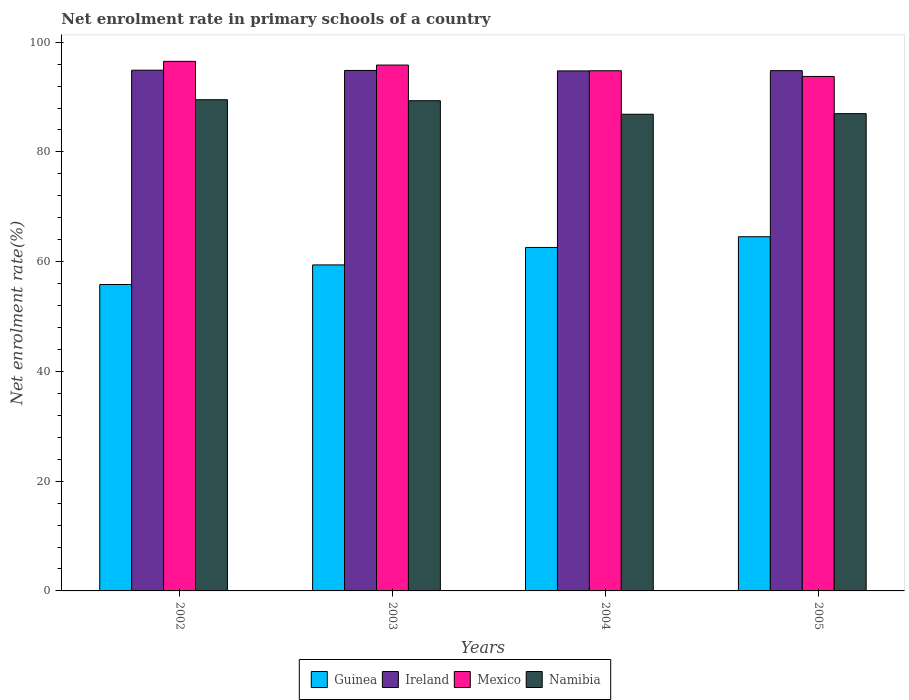How many different coloured bars are there?
Make the answer very short. 4. Are the number of bars per tick equal to the number of legend labels?
Offer a very short reply. Yes. How many bars are there on the 4th tick from the left?
Give a very brief answer. 4. What is the label of the 1st group of bars from the left?
Keep it short and to the point. 2002. In how many cases, is the number of bars for a given year not equal to the number of legend labels?
Your answer should be compact. 0. What is the net enrolment rate in primary schools in Ireland in 2003?
Your answer should be compact. 94.85. Across all years, what is the maximum net enrolment rate in primary schools in Mexico?
Your answer should be very brief. 96.51. Across all years, what is the minimum net enrolment rate in primary schools in Guinea?
Give a very brief answer. 55.84. In which year was the net enrolment rate in primary schools in Ireland maximum?
Ensure brevity in your answer.  2002. In which year was the net enrolment rate in primary schools in Ireland minimum?
Provide a short and direct response. 2004. What is the total net enrolment rate in primary schools in Guinea in the graph?
Your answer should be compact. 242.38. What is the difference between the net enrolment rate in primary schools in Ireland in 2002 and that in 2005?
Keep it short and to the point. 0.08. What is the difference between the net enrolment rate in primary schools in Mexico in 2003 and the net enrolment rate in primary schools in Ireland in 2002?
Give a very brief answer. 0.94. What is the average net enrolment rate in primary schools in Guinea per year?
Provide a short and direct response. 60.59. In the year 2003, what is the difference between the net enrolment rate in primary schools in Mexico and net enrolment rate in primary schools in Namibia?
Provide a short and direct response. 6.5. In how many years, is the net enrolment rate in primary schools in Namibia greater than 84 %?
Your answer should be compact. 4. What is the ratio of the net enrolment rate in primary schools in Ireland in 2003 to that in 2004?
Offer a terse response. 1. Is the net enrolment rate in primary schools in Mexico in 2003 less than that in 2005?
Give a very brief answer. No. What is the difference between the highest and the second highest net enrolment rate in primary schools in Guinea?
Make the answer very short. 1.95. What is the difference between the highest and the lowest net enrolment rate in primary schools in Guinea?
Provide a short and direct response. 8.71. In how many years, is the net enrolment rate in primary schools in Guinea greater than the average net enrolment rate in primary schools in Guinea taken over all years?
Keep it short and to the point. 2. What does the 1st bar from the left in 2002 represents?
Keep it short and to the point. Guinea. What does the 1st bar from the right in 2002 represents?
Your answer should be compact. Namibia. Is it the case that in every year, the sum of the net enrolment rate in primary schools in Mexico and net enrolment rate in primary schools in Ireland is greater than the net enrolment rate in primary schools in Namibia?
Your answer should be compact. Yes. How many bars are there?
Your response must be concise. 16. What is the difference between two consecutive major ticks on the Y-axis?
Give a very brief answer. 20. Does the graph contain any zero values?
Your response must be concise. No. Does the graph contain grids?
Offer a very short reply. No. How many legend labels are there?
Your answer should be compact. 4. What is the title of the graph?
Give a very brief answer. Net enrolment rate in primary schools of a country. Does "San Marino" appear as one of the legend labels in the graph?
Give a very brief answer. No. What is the label or title of the X-axis?
Provide a succinct answer. Years. What is the label or title of the Y-axis?
Offer a terse response. Net enrolment rate(%). What is the Net enrolment rate(%) in Guinea in 2002?
Ensure brevity in your answer.  55.84. What is the Net enrolment rate(%) in Ireland in 2002?
Give a very brief answer. 94.89. What is the Net enrolment rate(%) of Mexico in 2002?
Offer a very short reply. 96.51. What is the Net enrolment rate(%) in Namibia in 2002?
Provide a short and direct response. 89.51. What is the Net enrolment rate(%) of Guinea in 2003?
Offer a very short reply. 59.41. What is the Net enrolment rate(%) in Ireland in 2003?
Your answer should be very brief. 94.85. What is the Net enrolment rate(%) in Mexico in 2003?
Offer a terse response. 95.83. What is the Net enrolment rate(%) of Namibia in 2003?
Offer a very short reply. 89.33. What is the Net enrolment rate(%) in Guinea in 2004?
Offer a very short reply. 62.59. What is the Net enrolment rate(%) of Ireland in 2004?
Provide a short and direct response. 94.77. What is the Net enrolment rate(%) of Mexico in 2004?
Give a very brief answer. 94.8. What is the Net enrolment rate(%) of Namibia in 2004?
Provide a short and direct response. 86.87. What is the Net enrolment rate(%) of Guinea in 2005?
Keep it short and to the point. 64.54. What is the Net enrolment rate(%) of Ireland in 2005?
Give a very brief answer. 94.81. What is the Net enrolment rate(%) of Mexico in 2005?
Offer a very short reply. 93.75. What is the Net enrolment rate(%) of Namibia in 2005?
Your answer should be very brief. 86.98. Across all years, what is the maximum Net enrolment rate(%) of Guinea?
Make the answer very short. 64.54. Across all years, what is the maximum Net enrolment rate(%) of Ireland?
Offer a terse response. 94.89. Across all years, what is the maximum Net enrolment rate(%) in Mexico?
Make the answer very short. 96.51. Across all years, what is the maximum Net enrolment rate(%) in Namibia?
Offer a very short reply. 89.51. Across all years, what is the minimum Net enrolment rate(%) in Guinea?
Offer a terse response. 55.84. Across all years, what is the minimum Net enrolment rate(%) in Ireland?
Your answer should be very brief. 94.77. Across all years, what is the minimum Net enrolment rate(%) in Mexico?
Your response must be concise. 93.75. Across all years, what is the minimum Net enrolment rate(%) of Namibia?
Provide a short and direct response. 86.87. What is the total Net enrolment rate(%) in Guinea in the graph?
Your response must be concise. 242.38. What is the total Net enrolment rate(%) in Ireland in the graph?
Offer a very short reply. 379.32. What is the total Net enrolment rate(%) of Mexico in the graph?
Provide a succinct answer. 380.89. What is the total Net enrolment rate(%) of Namibia in the graph?
Offer a terse response. 352.69. What is the difference between the Net enrolment rate(%) of Guinea in 2002 and that in 2003?
Keep it short and to the point. -3.57. What is the difference between the Net enrolment rate(%) of Ireland in 2002 and that in 2003?
Your answer should be compact. 0.05. What is the difference between the Net enrolment rate(%) in Mexico in 2002 and that in 2003?
Provide a succinct answer. 0.68. What is the difference between the Net enrolment rate(%) in Namibia in 2002 and that in 2003?
Your response must be concise. 0.18. What is the difference between the Net enrolment rate(%) in Guinea in 2002 and that in 2004?
Provide a short and direct response. -6.75. What is the difference between the Net enrolment rate(%) of Ireland in 2002 and that in 2004?
Your answer should be very brief. 0.13. What is the difference between the Net enrolment rate(%) in Mexico in 2002 and that in 2004?
Your answer should be compact. 1.71. What is the difference between the Net enrolment rate(%) of Namibia in 2002 and that in 2004?
Offer a terse response. 2.65. What is the difference between the Net enrolment rate(%) of Guinea in 2002 and that in 2005?
Offer a terse response. -8.71. What is the difference between the Net enrolment rate(%) in Ireland in 2002 and that in 2005?
Provide a short and direct response. 0.08. What is the difference between the Net enrolment rate(%) in Mexico in 2002 and that in 2005?
Provide a short and direct response. 2.75. What is the difference between the Net enrolment rate(%) in Namibia in 2002 and that in 2005?
Offer a terse response. 2.54. What is the difference between the Net enrolment rate(%) in Guinea in 2003 and that in 2004?
Provide a short and direct response. -3.18. What is the difference between the Net enrolment rate(%) in Ireland in 2003 and that in 2004?
Offer a very short reply. 0.08. What is the difference between the Net enrolment rate(%) of Mexico in 2003 and that in 2004?
Your answer should be compact. 1.03. What is the difference between the Net enrolment rate(%) of Namibia in 2003 and that in 2004?
Offer a very short reply. 2.47. What is the difference between the Net enrolment rate(%) of Guinea in 2003 and that in 2005?
Your answer should be very brief. -5.13. What is the difference between the Net enrolment rate(%) in Ireland in 2003 and that in 2005?
Ensure brevity in your answer.  0.03. What is the difference between the Net enrolment rate(%) in Mexico in 2003 and that in 2005?
Your response must be concise. 2.08. What is the difference between the Net enrolment rate(%) of Namibia in 2003 and that in 2005?
Provide a succinct answer. 2.36. What is the difference between the Net enrolment rate(%) of Guinea in 2004 and that in 2005?
Provide a succinct answer. -1.95. What is the difference between the Net enrolment rate(%) of Ireland in 2004 and that in 2005?
Make the answer very short. -0.05. What is the difference between the Net enrolment rate(%) of Mexico in 2004 and that in 2005?
Your response must be concise. 1.04. What is the difference between the Net enrolment rate(%) of Namibia in 2004 and that in 2005?
Your response must be concise. -0.11. What is the difference between the Net enrolment rate(%) of Guinea in 2002 and the Net enrolment rate(%) of Ireland in 2003?
Provide a succinct answer. -39.01. What is the difference between the Net enrolment rate(%) of Guinea in 2002 and the Net enrolment rate(%) of Mexico in 2003?
Give a very brief answer. -40. What is the difference between the Net enrolment rate(%) of Guinea in 2002 and the Net enrolment rate(%) of Namibia in 2003?
Give a very brief answer. -33.5. What is the difference between the Net enrolment rate(%) in Ireland in 2002 and the Net enrolment rate(%) in Mexico in 2003?
Ensure brevity in your answer.  -0.94. What is the difference between the Net enrolment rate(%) of Ireland in 2002 and the Net enrolment rate(%) of Namibia in 2003?
Your answer should be very brief. 5.56. What is the difference between the Net enrolment rate(%) of Mexico in 2002 and the Net enrolment rate(%) of Namibia in 2003?
Your response must be concise. 7.17. What is the difference between the Net enrolment rate(%) in Guinea in 2002 and the Net enrolment rate(%) in Ireland in 2004?
Provide a short and direct response. -38.93. What is the difference between the Net enrolment rate(%) in Guinea in 2002 and the Net enrolment rate(%) in Mexico in 2004?
Provide a short and direct response. -38.96. What is the difference between the Net enrolment rate(%) of Guinea in 2002 and the Net enrolment rate(%) of Namibia in 2004?
Provide a succinct answer. -31.03. What is the difference between the Net enrolment rate(%) of Ireland in 2002 and the Net enrolment rate(%) of Mexico in 2004?
Your answer should be very brief. 0.1. What is the difference between the Net enrolment rate(%) in Ireland in 2002 and the Net enrolment rate(%) in Namibia in 2004?
Your answer should be compact. 8.03. What is the difference between the Net enrolment rate(%) in Mexico in 2002 and the Net enrolment rate(%) in Namibia in 2004?
Offer a very short reply. 9.64. What is the difference between the Net enrolment rate(%) in Guinea in 2002 and the Net enrolment rate(%) in Ireland in 2005?
Offer a very short reply. -38.98. What is the difference between the Net enrolment rate(%) in Guinea in 2002 and the Net enrolment rate(%) in Mexico in 2005?
Offer a terse response. -37.92. What is the difference between the Net enrolment rate(%) in Guinea in 2002 and the Net enrolment rate(%) in Namibia in 2005?
Provide a succinct answer. -31.14. What is the difference between the Net enrolment rate(%) in Ireland in 2002 and the Net enrolment rate(%) in Mexico in 2005?
Ensure brevity in your answer.  1.14. What is the difference between the Net enrolment rate(%) of Ireland in 2002 and the Net enrolment rate(%) of Namibia in 2005?
Offer a very short reply. 7.92. What is the difference between the Net enrolment rate(%) of Mexico in 2002 and the Net enrolment rate(%) of Namibia in 2005?
Provide a short and direct response. 9.53. What is the difference between the Net enrolment rate(%) in Guinea in 2003 and the Net enrolment rate(%) in Ireland in 2004?
Your answer should be very brief. -35.36. What is the difference between the Net enrolment rate(%) of Guinea in 2003 and the Net enrolment rate(%) of Mexico in 2004?
Offer a very short reply. -35.39. What is the difference between the Net enrolment rate(%) of Guinea in 2003 and the Net enrolment rate(%) of Namibia in 2004?
Offer a terse response. -27.46. What is the difference between the Net enrolment rate(%) in Ireland in 2003 and the Net enrolment rate(%) in Mexico in 2004?
Your response must be concise. 0.05. What is the difference between the Net enrolment rate(%) in Ireland in 2003 and the Net enrolment rate(%) in Namibia in 2004?
Make the answer very short. 7.98. What is the difference between the Net enrolment rate(%) of Mexico in 2003 and the Net enrolment rate(%) of Namibia in 2004?
Make the answer very short. 8.96. What is the difference between the Net enrolment rate(%) in Guinea in 2003 and the Net enrolment rate(%) in Ireland in 2005?
Your response must be concise. -35.4. What is the difference between the Net enrolment rate(%) in Guinea in 2003 and the Net enrolment rate(%) in Mexico in 2005?
Offer a terse response. -34.35. What is the difference between the Net enrolment rate(%) in Guinea in 2003 and the Net enrolment rate(%) in Namibia in 2005?
Offer a terse response. -27.57. What is the difference between the Net enrolment rate(%) in Ireland in 2003 and the Net enrolment rate(%) in Mexico in 2005?
Give a very brief answer. 1.09. What is the difference between the Net enrolment rate(%) in Ireland in 2003 and the Net enrolment rate(%) in Namibia in 2005?
Offer a terse response. 7.87. What is the difference between the Net enrolment rate(%) of Mexico in 2003 and the Net enrolment rate(%) of Namibia in 2005?
Make the answer very short. 8.85. What is the difference between the Net enrolment rate(%) of Guinea in 2004 and the Net enrolment rate(%) of Ireland in 2005?
Provide a short and direct response. -32.22. What is the difference between the Net enrolment rate(%) in Guinea in 2004 and the Net enrolment rate(%) in Mexico in 2005?
Your answer should be compact. -31.16. What is the difference between the Net enrolment rate(%) of Guinea in 2004 and the Net enrolment rate(%) of Namibia in 2005?
Offer a terse response. -24.39. What is the difference between the Net enrolment rate(%) in Ireland in 2004 and the Net enrolment rate(%) in Mexico in 2005?
Keep it short and to the point. 1.01. What is the difference between the Net enrolment rate(%) of Ireland in 2004 and the Net enrolment rate(%) of Namibia in 2005?
Your response must be concise. 7.79. What is the difference between the Net enrolment rate(%) of Mexico in 2004 and the Net enrolment rate(%) of Namibia in 2005?
Provide a succinct answer. 7.82. What is the average Net enrolment rate(%) in Guinea per year?
Your answer should be compact. 60.59. What is the average Net enrolment rate(%) of Ireland per year?
Give a very brief answer. 94.83. What is the average Net enrolment rate(%) in Mexico per year?
Offer a very short reply. 95.22. What is the average Net enrolment rate(%) of Namibia per year?
Make the answer very short. 88.17. In the year 2002, what is the difference between the Net enrolment rate(%) in Guinea and Net enrolment rate(%) in Ireland?
Provide a short and direct response. -39.06. In the year 2002, what is the difference between the Net enrolment rate(%) of Guinea and Net enrolment rate(%) of Mexico?
Make the answer very short. -40.67. In the year 2002, what is the difference between the Net enrolment rate(%) in Guinea and Net enrolment rate(%) in Namibia?
Offer a terse response. -33.68. In the year 2002, what is the difference between the Net enrolment rate(%) of Ireland and Net enrolment rate(%) of Mexico?
Make the answer very short. -1.61. In the year 2002, what is the difference between the Net enrolment rate(%) in Ireland and Net enrolment rate(%) in Namibia?
Provide a short and direct response. 5.38. In the year 2002, what is the difference between the Net enrolment rate(%) in Mexico and Net enrolment rate(%) in Namibia?
Your answer should be compact. 6.99. In the year 2003, what is the difference between the Net enrolment rate(%) in Guinea and Net enrolment rate(%) in Ireland?
Keep it short and to the point. -35.44. In the year 2003, what is the difference between the Net enrolment rate(%) of Guinea and Net enrolment rate(%) of Mexico?
Keep it short and to the point. -36.42. In the year 2003, what is the difference between the Net enrolment rate(%) in Guinea and Net enrolment rate(%) in Namibia?
Make the answer very short. -29.92. In the year 2003, what is the difference between the Net enrolment rate(%) in Ireland and Net enrolment rate(%) in Mexico?
Your answer should be very brief. -0.98. In the year 2003, what is the difference between the Net enrolment rate(%) of Ireland and Net enrolment rate(%) of Namibia?
Give a very brief answer. 5.51. In the year 2003, what is the difference between the Net enrolment rate(%) of Mexico and Net enrolment rate(%) of Namibia?
Keep it short and to the point. 6.5. In the year 2004, what is the difference between the Net enrolment rate(%) in Guinea and Net enrolment rate(%) in Ireland?
Provide a short and direct response. -32.18. In the year 2004, what is the difference between the Net enrolment rate(%) of Guinea and Net enrolment rate(%) of Mexico?
Offer a terse response. -32.21. In the year 2004, what is the difference between the Net enrolment rate(%) in Guinea and Net enrolment rate(%) in Namibia?
Your answer should be very brief. -24.28. In the year 2004, what is the difference between the Net enrolment rate(%) in Ireland and Net enrolment rate(%) in Mexico?
Your answer should be very brief. -0.03. In the year 2004, what is the difference between the Net enrolment rate(%) of Ireland and Net enrolment rate(%) of Namibia?
Offer a very short reply. 7.9. In the year 2004, what is the difference between the Net enrolment rate(%) in Mexico and Net enrolment rate(%) in Namibia?
Offer a very short reply. 7.93. In the year 2005, what is the difference between the Net enrolment rate(%) in Guinea and Net enrolment rate(%) in Ireland?
Your answer should be compact. -30.27. In the year 2005, what is the difference between the Net enrolment rate(%) in Guinea and Net enrolment rate(%) in Mexico?
Your response must be concise. -29.21. In the year 2005, what is the difference between the Net enrolment rate(%) in Guinea and Net enrolment rate(%) in Namibia?
Provide a short and direct response. -22.43. In the year 2005, what is the difference between the Net enrolment rate(%) of Ireland and Net enrolment rate(%) of Mexico?
Your answer should be very brief. 1.06. In the year 2005, what is the difference between the Net enrolment rate(%) in Ireland and Net enrolment rate(%) in Namibia?
Ensure brevity in your answer.  7.83. In the year 2005, what is the difference between the Net enrolment rate(%) in Mexico and Net enrolment rate(%) in Namibia?
Keep it short and to the point. 6.78. What is the ratio of the Net enrolment rate(%) of Guinea in 2002 to that in 2003?
Offer a very short reply. 0.94. What is the ratio of the Net enrolment rate(%) in Ireland in 2002 to that in 2003?
Your answer should be very brief. 1. What is the ratio of the Net enrolment rate(%) in Mexico in 2002 to that in 2003?
Keep it short and to the point. 1.01. What is the ratio of the Net enrolment rate(%) in Guinea in 2002 to that in 2004?
Your answer should be compact. 0.89. What is the ratio of the Net enrolment rate(%) in Ireland in 2002 to that in 2004?
Ensure brevity in your answer.  1. What is the ratio of the Net enrolment rate(%) in Namibia in 2002 to that in 2004?
Ensure brevity in your answer.  1.03. What is the ratio of the Net enrolment rate(%) of Guinea in 2002 to that in 2005?
Offer a terse response. 0.87. What is the ratio of the Net enrolment rate(%) of Mexico in 2002 to that in 2005?
Give a very brief answer. 1.03. What is the ratio of the Net enrolment rate(%) in Namibia in 2002 to that in 2005?
Keep it short and to the point. 1.03. What is the ratio of the Net enrolment rate(%) in Guinea in 2003 to that in 2004?
Give a very brief answer. 0.95. What is the ratio of the Net enrolment rate(%) of Mexico in 2003 to that in 2004?
Your answer should be very brief. 1.01. What is the ratio of the Net enrolment rate(%) in Namibia in 2003 to that in 2004?
Provide a succinct answer. 1.03. What is the ratio of the Net enrolment rate(%) of Guinea in 2003 to that in 2005?
Your answer should be compact. 0.92. What is the ratio of the Net enrolment rate(%) of Mexico in 2003 to that in 2005?
Ensure brevity in your answer.  1.02. What is the ratio of the Net enrolment rate(%) in Namibia in 2003 to that in 2005?
Make the answer very short. 1.03. What is the ratio of the Net enrolment rate(%) of Guinea in 2004 to that in 2005?
Provide a succinct answer. 0.97. What is the ratio of the Net enrolment rate(%) of Mexico in 2004 to that in 2005?
Give a very brief answer. 1.01. What is the difference between the highest and the second highest Net enrolment rate(%) of Guinea?
Offer a terse response. 1.95. What is the difference between the highest and the second highest Net enrolment rate(%) of Ireland?
Your answer should be compact. 0.05. What is the difference between the highest and the second highest Net enrolment rate(%) of Mexico?
Provide a short and direct response. 0.68. What is the difference between the highest and the second highest Net enrolment rate(%) in Namibia?
Provide a short and direct response. 0.18. What is the difference between the highest and the lowest Net enrolment rate(%) of Guinea?
Give a very brief answer. 8.71. What is the difference between the highest and the lowest Net enrolment rate(%) in Ireland?
Give a very brief answer. 0.13. What is the difference between the highest and the lowest Net enrolment rate(%) in Mexico?
Keep it short and to the point. 2.75. What is the difference between the highest and the lowest Net enrolment rate(%) of Namibia?
Provide a succinct answer. 2.65. 